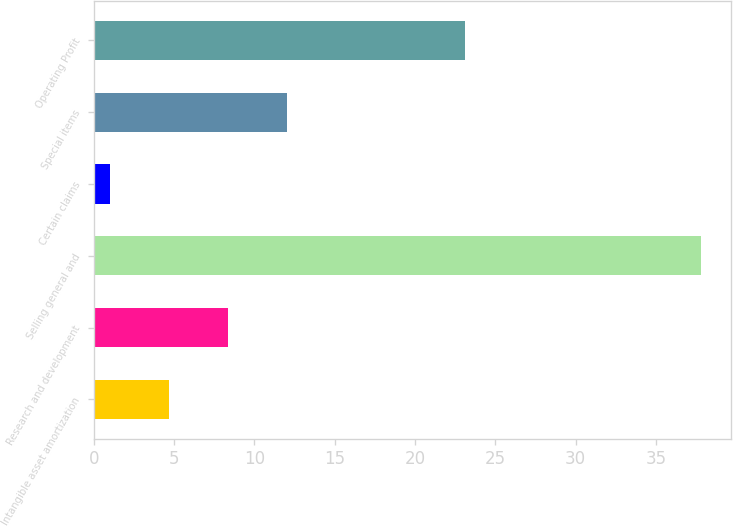<chart> <loc_0><loc_0><loc_500><loc_500><bar_chart><fcel>Intangible asset amortization<fcel>Research and development<fcel>Selling general and<fcel>Certain claims<fcel>Special items<fcel>Operating Profit<nl><fcel>4.68<fcel>8.36<fcel>37.8<fcel>1<fcel>12.04<fcel>23.1<nl></chart> 